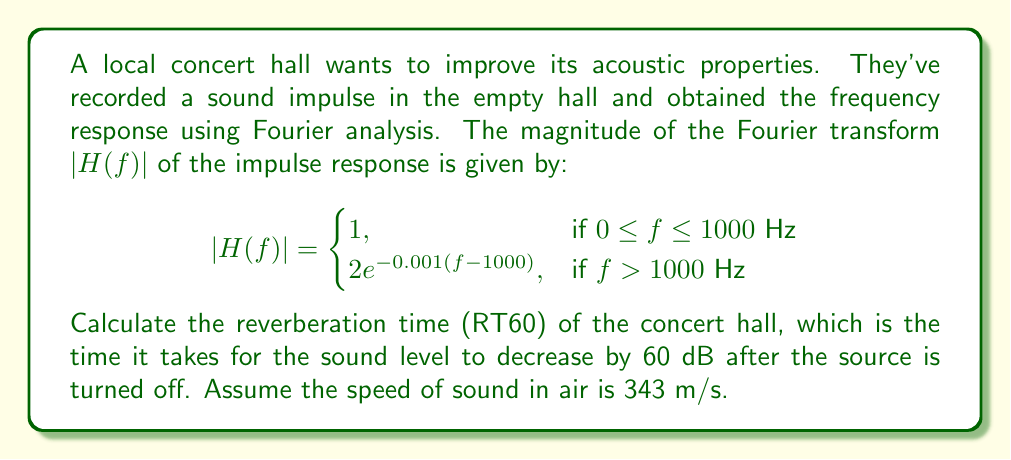Teach me how to tackle this problem. Let's approach this step-by-step:

1) The reverberation time (RT60) is related to the rate of decay of the impulse response. We can estimate this from the frequency response.

2) The decay rate in the frequency domain corresponds to the exponential part of $|H(f)|$ for $f > 1000$ Hz:

   $|H(f)| = 2e^{-0.001(f-1000)}$

3) We need to convert this to the time domain. The Fourier transform of an exponential decay in frequency is a Lorentzian function in time:

   $h(t) \propto \frac{1}{1 + (2\pi\alpha t)^2}$

   where $\alpha$ is the decay rate in the frequency domain.

4) From our $|H(f)|$, we can see that $\alpha = 0.001$.

5) The energy of the impulse response decays as the square of its amplitude:

   $E(t) \propto \frac{1}{[1 + (2\pi\alpha t)^2]^2}$

6) We want to find the time $t$ when $E(t) = 10^{-6}E(0)$ (60 dB decrease):

   $\frac{1}{[1 + (2\pi\alpha t)^2]^2} = 10^{-6}$

7) Solving this equation:

   $1 + (2\pi\alpha t)^2 = 10^{3/2}$
   $(2\pi\alpha t)^2 = 10^{3/2} - 1$
   $t = \frac{\sqrt{10^{3/2} - 1}}{2\pi\alpha}$

8) Substituting $\alpha = 0.001$:

   $t = \frac{\sqrt{10^{3/2} - 1}}{2\pi(0.001)} \approx 2.38$ seconds

Therefore, the reverberation time (RT60) of the concert hall is approximately 2.38 seconds.
Answer: The reverberation time (RT60) of the concert hall is approximately 2.38 seconds. 